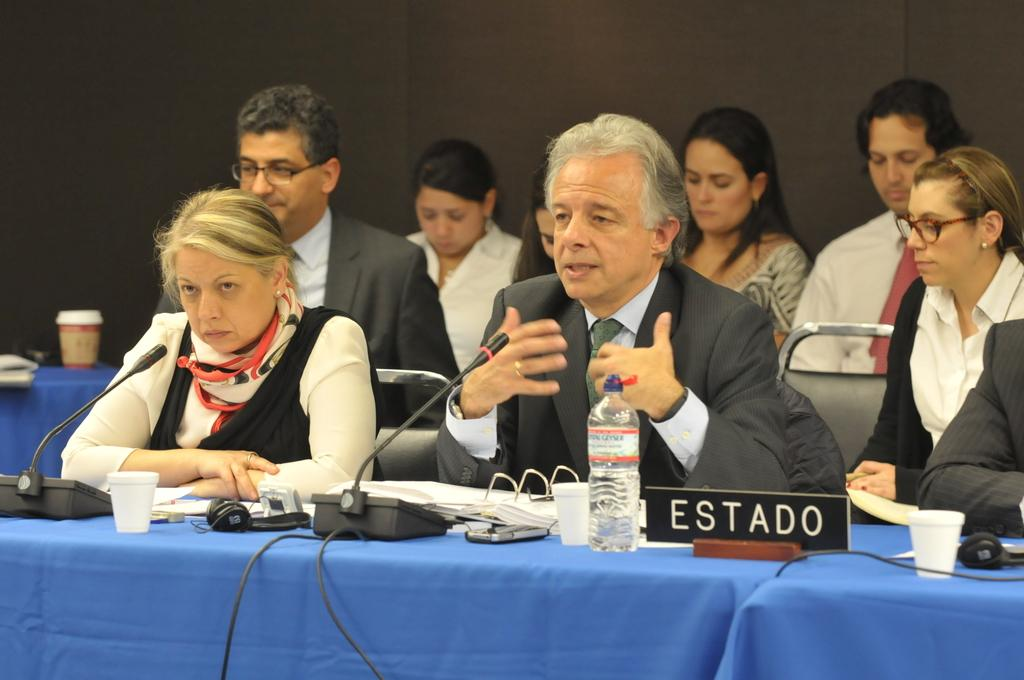What are the people in the image doing? There are persons sitting in front of the table in the image. What object is present on the table that is commonly used for amplifying sound? There is a microphone on the table. What two items can be seen on the table that are typically used for holding liquids? There is a bottle and a glass on the table. What small electronic device is present on the table? There is a mouse on the table. What type of wires can be seen on the table? There are cable wires on the table. What type of marble is visible on the table in the image? There is no marble present on the table in the image. What kind of agreement is being discussed by the persons in the image? The image does not provide any information about an agreement being discussed. 